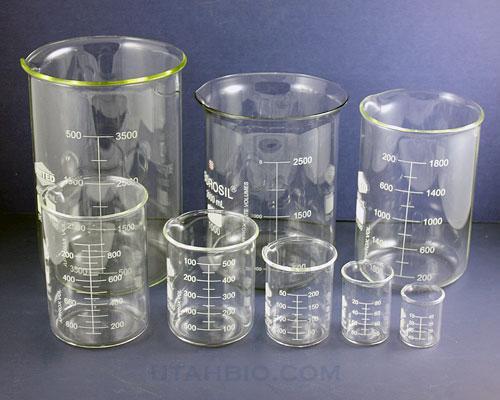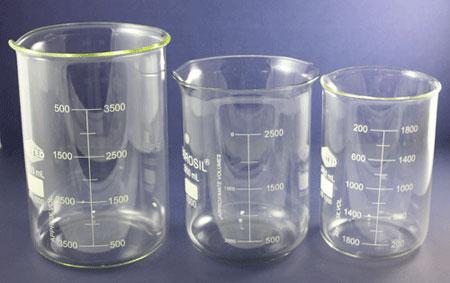The first image is the image on the left, the second image is the image on the right. Assess this claim about the two images: "There is no less than one clear beaker filled with a blue liquid". Correct or not? Answer yes or no. No. The first image is the image on the left, the second image is the image on the right. Considering the images on both sides, is "blu liquid is in the beaker" valid? Answer yes or no. No. 